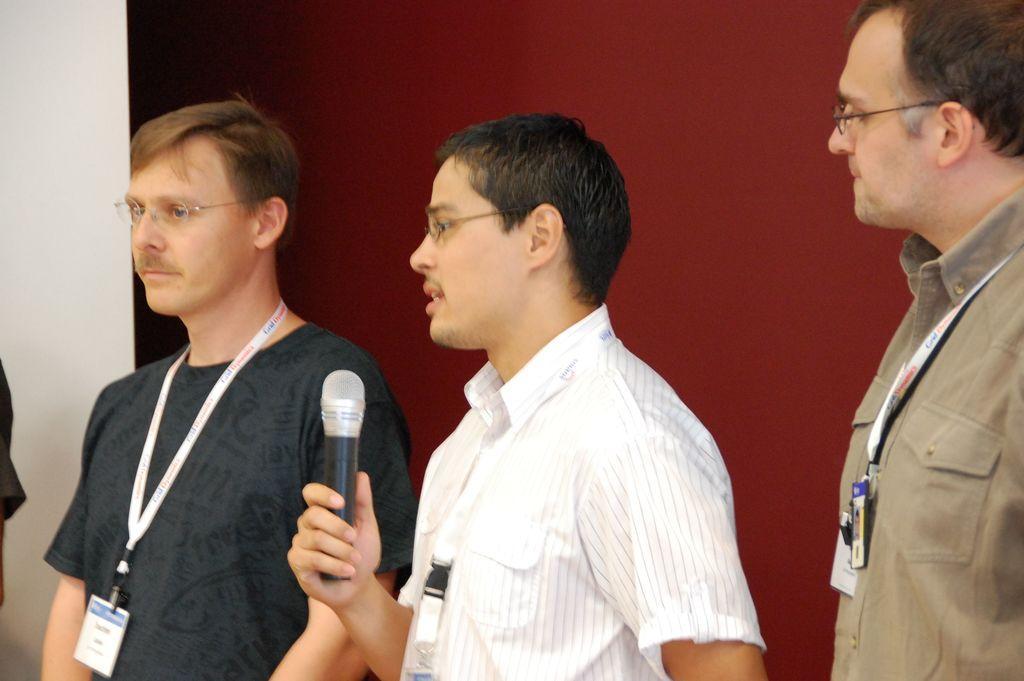How would you summarize this image in a sentence or two? There are three people standing and wearing white color tags. The person in the middle is holding a mike and speaking. Background looks maroon in color. 